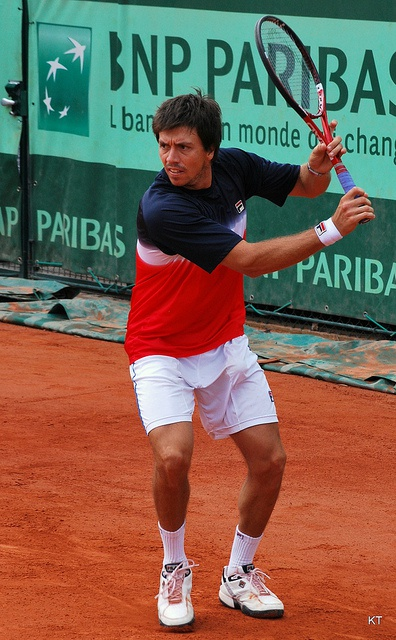Describe the objects in this image and their specific colors. I can see people in turquoise, black, maroon, and lavender tones and tennis racket in turquoise, black, gray, and teal tones in this image. 